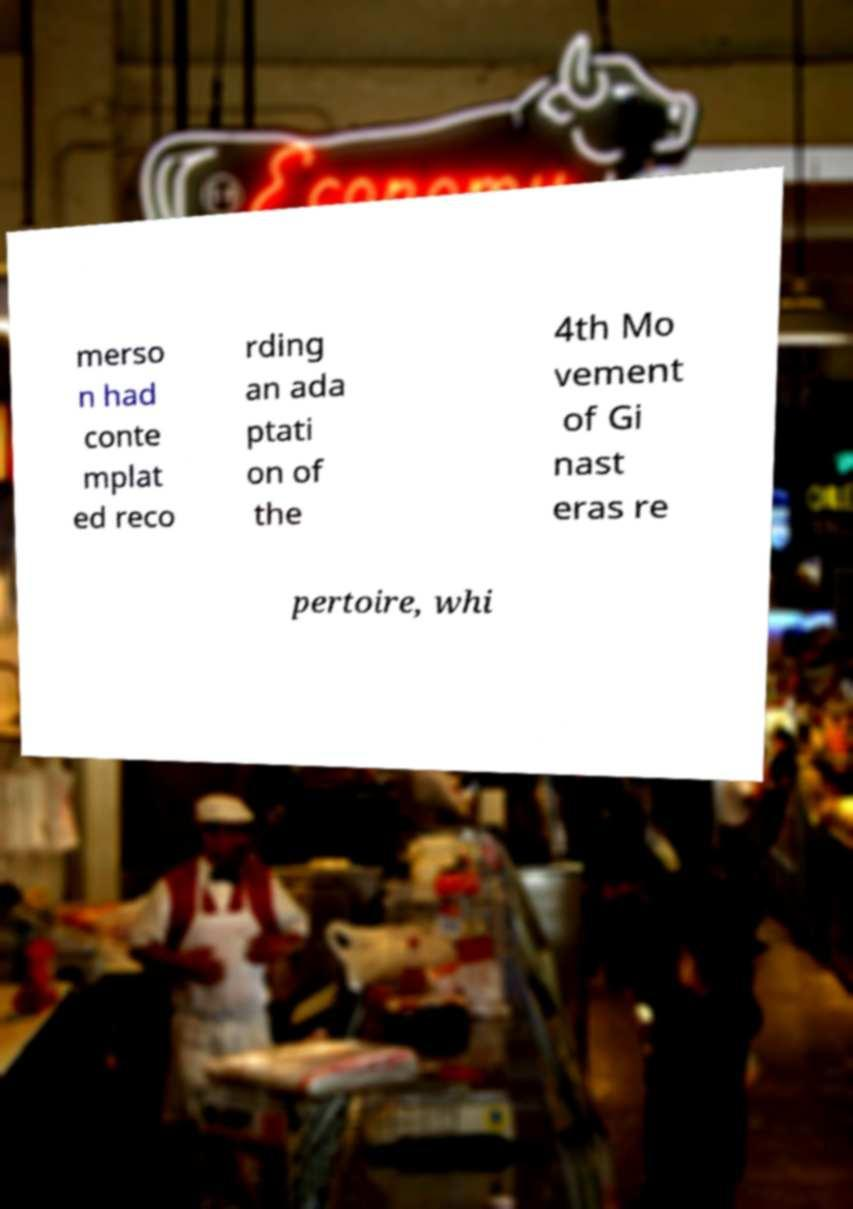For documentation purposes, I need the text within this image transcribed. Could you provide that? merso n had conte mplat ed reco rding an ada ptati on of the 4th Mo vement of Gi nast eras re pertoire, whi 